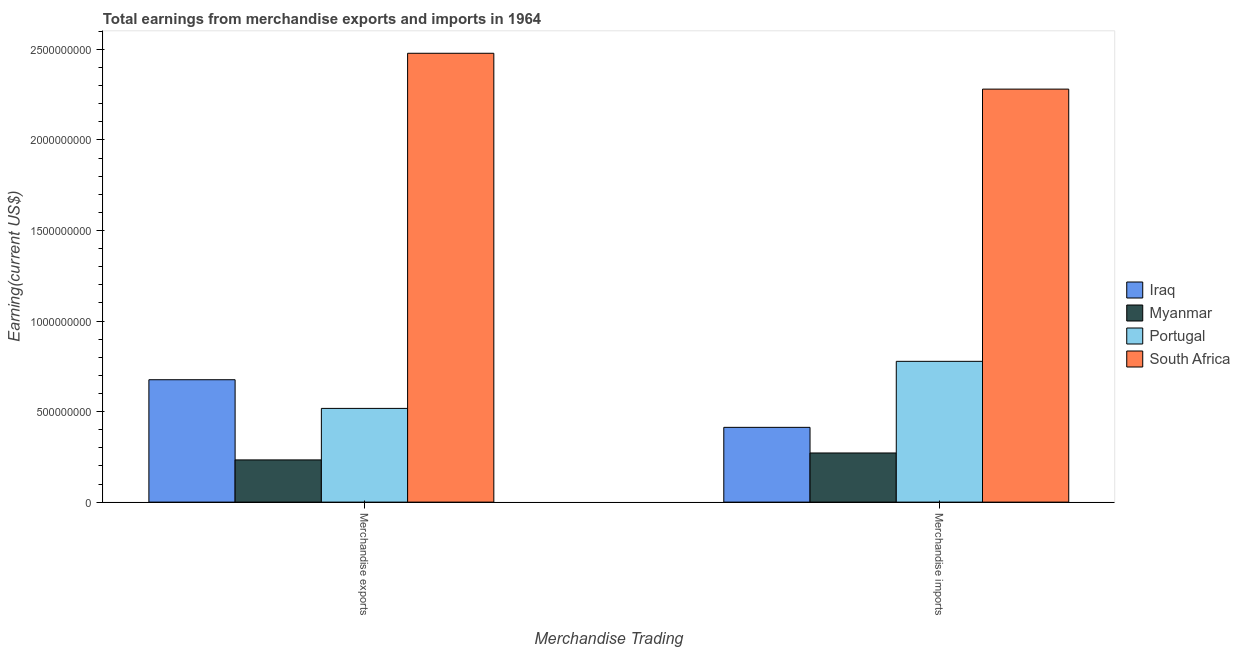How many groups of bars are there?
Keep it short and to the point. 2. What is the label of the 2nd group of bars from the left?
Make the answer very short. Merchandise imports. What is the earnings from merchandise exports in Portugal?
Keep it short and to the point. 5.18e+08. Across all countries, what is the maximum earnings from merchandise imports?
Offer a terse response. 2.28e+09. Across all countries, what is the minimum earnings from merchandise exports?
Your answer should be very brief. 2.33e+08. In which country was the earnings from merchandise exports maximum?
Ensure brevity in your answer.  South Africa. In which country was the earnings from merchandise imports minimum?
Your answer should be very brief. Myanmar. What is the total earnings from merchandise exports in the graph?
Offer a very short reply. 3.91e+09. What is the difference between the earnings from merchandise exports in Portugal and that in Myanmar?
Offer a very short reply. 2.85e+08. What is the difference between the earnings from merchandise imports in Portugal and the earnings from merchandise exports in Myanmar?
Your response must be concise. 5.44e+08. What is the average earnings from merchandise exports per country?
Provide a succinct answer. 9.76e+08. What is the difference between the earnings from merchandise imports and earnings from merchandise exports in Iraq?
Offer a very short reply. -2.63e+08. In how many countries, is the earnings from merchandise exports greater than 1900000000 US$?
Your response must be concise. 1. What is the ratio of the earnings from merchandise imports in Iraq to that in South Africa?
Provide a short and direct response. 0.18. Is the earnings from merchandise exports in South Africa less than that in Portugal?
Offer a terse response. No. In how many countries, is the earnings from merchandise imports greater than the average earnings from merchandise imports taken over all countries?
Ensure brevity in your answer.  1. What does the 3rd bar from the left in Merchandise exports represents?
Offer a very short reply. Portugal. What does the 1st bar from the right in Merchandise imports represents?
Provide a short and direct response. South Africa. How many countries are there in the graph?
Offer a terse response. 4. Are the values on the major ticks of Y-axis written in scientific E-notation?
Your answer should be compact. No. Does the graph contain any zero values?
Ensure brevity in your answer.  No. Does the graph contain grids?
Ensure brevity in your answer.  No. What is the title of the graph?
Provide a short and direct response. Total earnings from merchandise exports and imports in 1964. Does "Micronesia" appear as one of the legend labels in the graph?
Your answer should be very brief. No. What is the label or title of the X-axis?
Keep it short and to the point. Merchandise Trading. What is the label or title of the Y-axis?
Keep it short and to the point. Earning(current US$). What is the Earning(current US$) in Iraq in Merchandise exports?
Your response must be concise. 6.76e+08. What is the Earning(current US$) of Myanmar in Merchandise exports?
Ensure brevity in your answer.  2.33e+08. What is the Earning(current US$) in Portugal in Merchandise exports?
Give a very brief answer. 5.18e+08. What is the Earning(current US$) of South Africa in Merchandise exports?
Ensure brevity in your answer.  2.48e+09. What is the Earning(current US$) in Iraq in Merchandise imports?
Give a very brief answer. 4.13e+08. What is the Earning(current US$) of Myanmar in Merchandise imports?
Provide a succinct answer. 2.71e+08. What is the Earning(current US$) of Portugal in Merchandise imports?
Make the answer very short. 7.78e+08. What is the Earning(current US$) in South Africa in Merchandise imports?
Ensure brevity in your answer.  2.28e+09. Across all Merchandise Trading, what is the maximum Earning(current US$) of Iraq?
Keep it short and to the point. 6.76e+08. Across all Merchandise Trading, what is the maximum Earning(current US$) in Myanmar?
Keep it short and to the point. 2.71e+08. Across all Merchandise Trading, what is the maximum Earning(current US$) of Portugal?
Your response must be concise. 7.78e+08. Across all Merchandise Trading, what is the maximum Earning(current US$) in South Africa?
Your answer should be very brief. 2.48e+09. Across all Merchandise Trading, what is the minimum Earning(current US$) in Iraq?
Keep it short and to the point. 4.13e+08. Across all Merchandise Trading, what is the minimum Earning(current US$) of Myanmar?
Keep it short and to the point. 2.33e+08. Across all Merchandise Trading, what is the minimum Earning(current US$) in Portugal?
Offer a terse response. 5.18e+08. Across all Merchandise Trading, what is the minimum Earning(current US$) of South Africa?
Your response must be concise. 2.28e+09. What is the total Earning(current US$) of Iraq in the graph?
Make the answer very short. 1.09e+09. What is the total Earning(current US$) in Myanmar in the graph?
Provide a succinct answer. 5.05e+08. What is the total Earning(current US$) of Portugal in the graph?
Offer a terse response. 1.30e+09. What is the total Earning(current US$) of South Africa in the graph?
Keep it short and to the point. 4.76e+09. What is the difference between the Earning(current US$) of Iraq in Merchandise exports and that in Merchandise imports?
Make the answer very short. 2.63e+08. What is the difference between the Earning(current US$) of Myanmar in Merchandise exports and that in Merchandise imports?
Keep it short and to the point. -3.83e+07. What is the difference between the Earning(current US$) in Portugal in Merchandise exports and that in Merchandise imports?
Give a very brief answer. -2.60e+08. What is the difference between the Earning(current US$) in South Africa in Merchandise exports and that in Merchandise imports?
Provide a succinct answer. 1.98e+08. What is the difference between the Earning(current US$) of Iraq in Merchandise exports and the Earning(current US$) of Myanmar in Merchandise imports?
Offer a terse response. 4.05e+08. What is the difference between the Earning(current US$) in Iraq in Merchandise exports and the Earning(current US$) in Portugal in Merchandise imports?
Make the answer very short. -1.02e+08. What is the difference between the Earning(current US$) of Iraq in Merchandise exports and the Earning(current US$) of South Africa in Merchandise imports?
Provide a short and direct response. -1.61e+09. What is the difference between the Earning(current US$) in Myanmar in Merchandise exports and the Earning(current US$) in Portugal in Merchandise imports?
Offer a terse response. -5.44e+08. What is the difference between the Earning(current US$) of Myanmar in Merchandise exports and the Earning(current US$) of South Africa in Merchandise imports?
Your response must be concise. -2.05e+09. What is the difference between the Earning(current US$) in Portugal in Merchandise exports and the Earning(current US$) in South Africa in Merchandise imports?
Ensure brevity in your answer.  -1.76e+09. What is the average Earning(current US$) of Iraq per Merchandise Trading?
Offer a terse response. 5.44e+08. What is the average Earning(current US$) in Myanmar per Merchandise Trading?
Keep it short and to the point. 2.52e+08. What is the average Earning(current US$) in Portugal per Merchandise Trading?
Your response must be concise. 6.48e+08. What is the average Earning(current US$) in South Africa per Merchandise Trading?
Offer a very short reply. 2.38e+09. What is the difference between the Earning(current US$) in Iraq and Earning(current US$) in Myanmar in Merchandise exports?
Ensure brevity in your answer.  4.43e+08. What is the difference between the Earning(current US$) of Iraq and Earning(current US$) of Portugal in Merchandise exports?
Your answer should be compact. 1.58e+08. What is the difference between the Earning(current US$) in Iraq and Earning(current US$) in South Africa in Merchandise exports?
Ensure brevity in your answer.  -1.80e+09. What is the difference between the Earning(current US$) in Myanmar and Earning(current US$) in Portugal in Merchandise exports?
Provide a short and direct response. -2.85e+08. What is the difference between the Earning(current US$) of Myanmar and Earning(current US$) of South Africa in Merchandise exports?
Ensure brevity in your answer.  -2.25e+09. What is the difference between the Earning(current US$) of Portugal and Earning(current US$) of South Africa in Merchandise exports?
Provide a succinct answer. -1.96e+09. What is the difference between the Earning(current US$) of Iraq and Earning(current US$) of Myanmar in Merchandise imports?
Provide a succinct answer. 1.42e+08. What is the difference between the Earning(current US$) of Iraq and Earning(current US$) of Portugal in Merchandise imports?
Make the answer very short. -3.65e+08. What is the difference between the Earning(current US$) of Iraq and Earning(current US$) of South Africa in Merchandise imports?
Give a very brief answer. -1.87e+09. What is the difference between the Earning(current US$) of Myanmar and Earning(current US$) of Portugal in Merchandise imports?
Your response must be concise. -5.06e+08. What is the difference between the Earning(current US$) of Myanmar and Earning(current US$) of South Africa in Merchandise imports?
Offer a very short reply. -2.01e+09. What is the difference between the Earning(current US$) of Portugal and Earning(current US$) of South Africa in Merchandise imports?
Give a very brief answer. -1.50e+09. What is the ratio of the Earning(current US$) of Iraq in Merchandise exports to that in Merchandise imports?
Give a very brief answer. 1.64. What is the ratio of the Earning(current US$) in Myanmar in Merchandise exports to that in Merchandise imports?
Ensure brevity in your answer.  0.86. What is the ratio of the Earning(current US$) of Portugal in Merchandise exports to that in Merchandise imports?
Your answer should be compact. 0.67. What is the ratio of the Earning(current US$) of South Africa in Merchandise exports to that in Merchandise imports?
Your response must be concise. 1.09. What is the difference between the highest and the second highest Earning(current US$) in Iraq?
Your answer should be compact. 2.63e+08. What is the difference between the highest and the second highest Earning(current US$) of Myanmar?
Offer a very short reply. 3.83e+07. What is the difference between the highest and the second highest Earning(current US$) of Portugal?
Make the answer very short. 2.60e+08. What is the difference between the highest and the second highest Earning(current US$) of South Africa?
Keep it short and to the point. 1.98e+08. What is the difference between the highest and the lowest Earning(current US$) in Iraq?
Your response must be concise. 2.63e+08. What is the difference between the highest and the lowest Earning(current US$) of Myanmar?
Provide a short and direct response. 3.83e+07. What is the difference between the highest and the lowest Earning(current US$) of Portugal?
Keep it short and to the point. 2.60e+08. What is the difference between the highest and the lowest Earning(current US$) of South Africa?
Your response must be concise. 1.98e+08. 